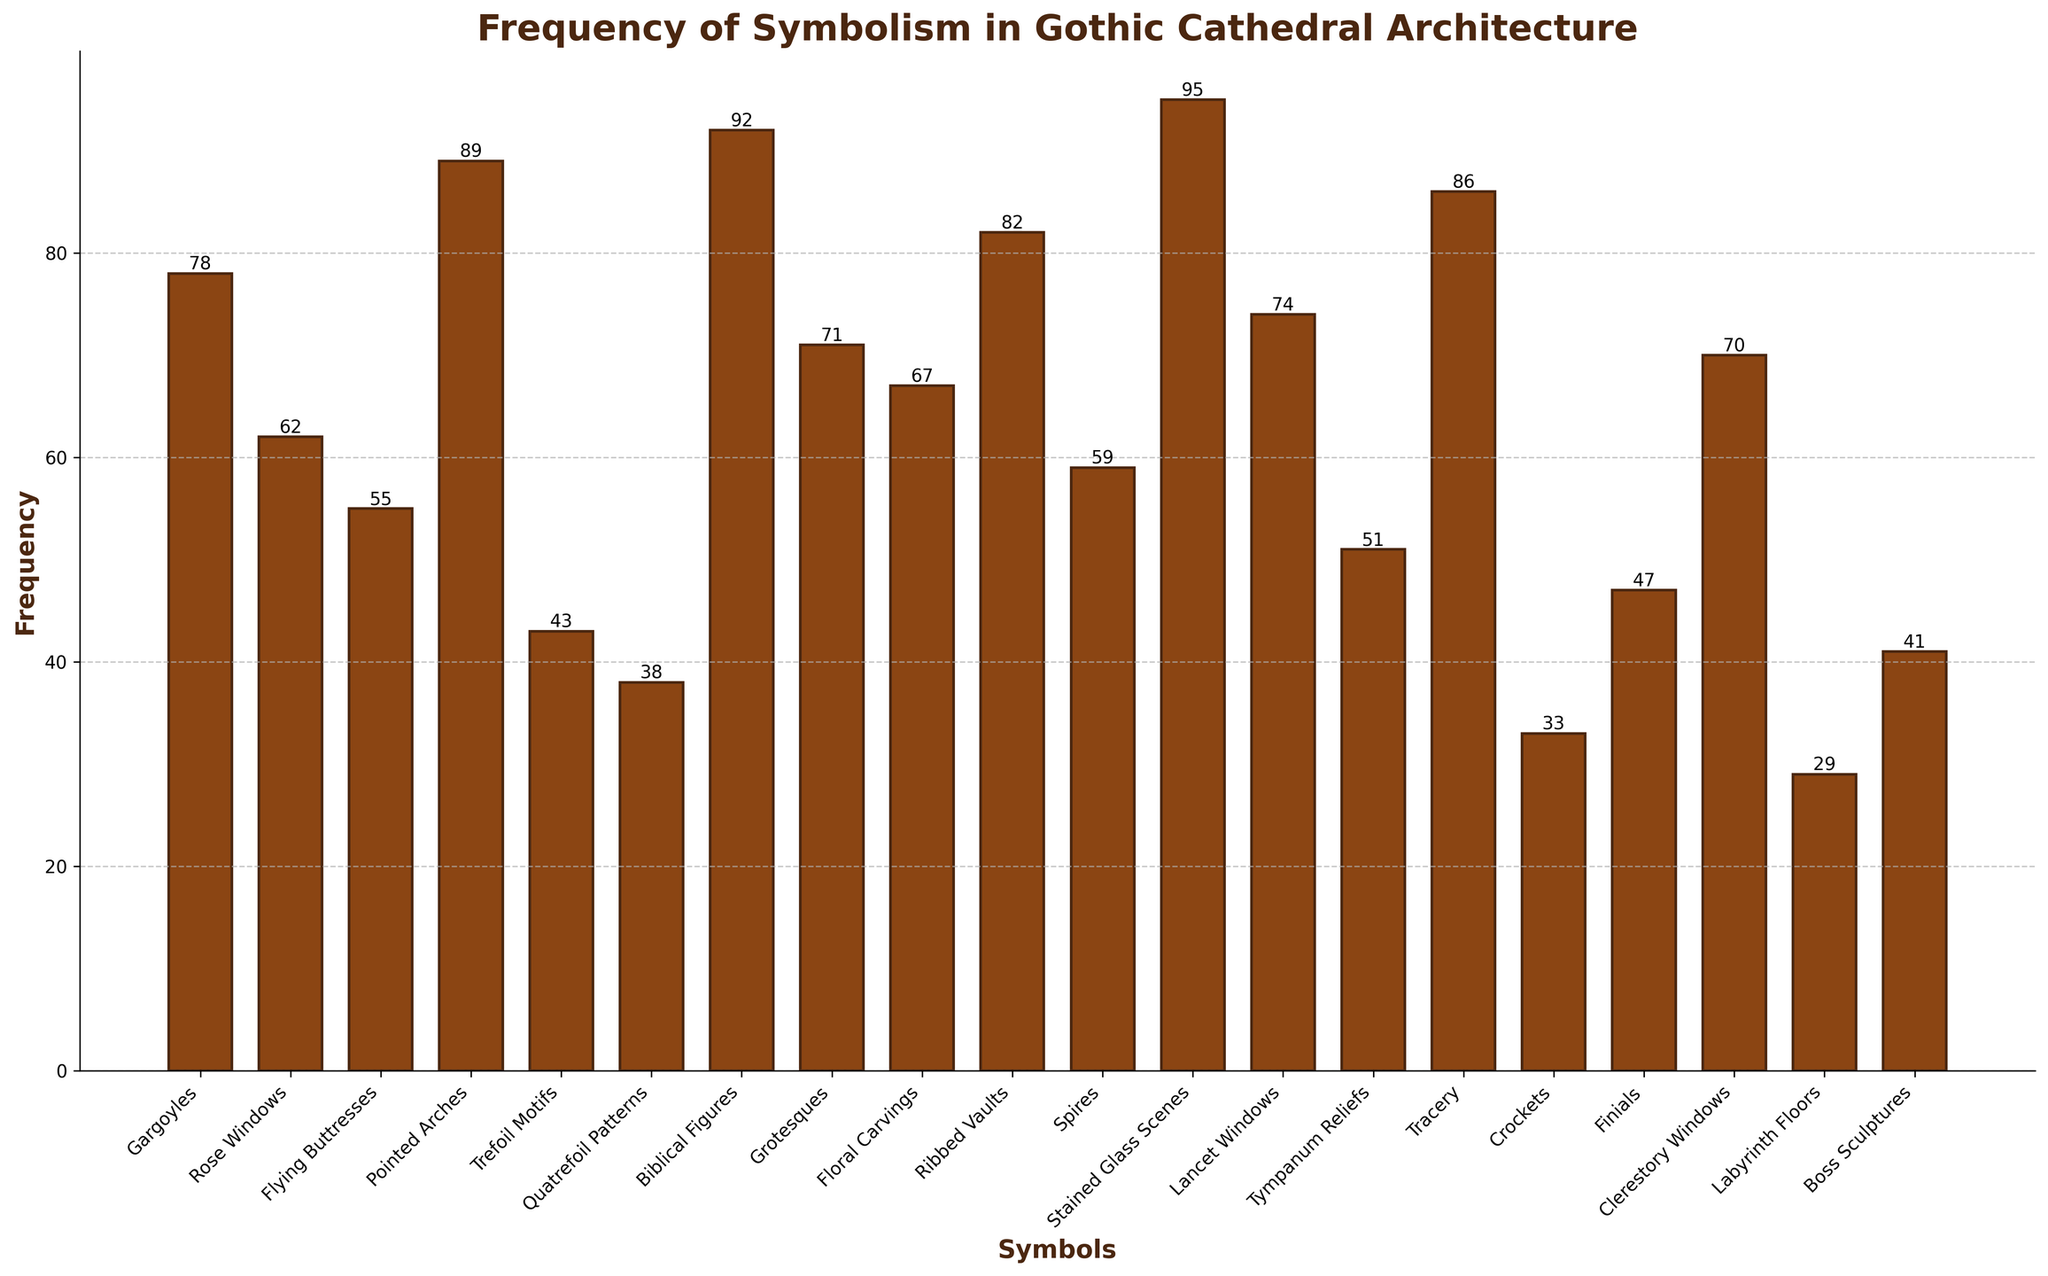What is the frequency of Biblical Figures in Gothic cathedral architecture? The figure presents bar heights corresponding to frequencies of different symbols. The bar labeled "Biblical Figures" reaches a height corresponding to 92.
Answer: 92 Which symbol appears more frequently: Gargoyles or Rose Windows? The heights of the bars labeled "Gargoyles" and "Rose Windows" show their respective frequencies. The height for Gargoyles is 78, while Rose Windows is 62. Since 78 is greater than 62, Gargoyles are more frequent.
Answer: Gargoyles What are the three least frequent symbols? The least frequent symbols are represented by the shortest bars in the figure. The bars with the smallest heights correspond to "Labyrinth Floors" (29), "Crockets" (33), and "Quatrefoil Patterns" (38).
Answer: Labyrinth Floors, Crockets, Quatrefoil Patterns How much more frequent are Pointed Arches than Trefoil Motifs? The bar for Pointed Arches has a frequency of 89 and Trefoil Motifs has 43. Subtract the frequency of Trefoil Motifs from that of Pointed Arches: 89 - 43 = 46.
Answer: 46 What symbols have frequencies greater than 80? Symbols with frequencies greater than 80 are represented by bars taller than the corresponding values on the y-axis. The bars for "Stained Glass Scenes" (95), "Biblical Figures" (92), "Ribbed Vaults" (82), "Pointed Arches" (89), and "Tracery" (86) exceed 80.
Answer: Stained Glass Scenes, Biblical Figures, Ribbed Vaults, Pointed Arches, Tracery What is the total frequency of symbols containing window-related elements? Sum the frequencies for symbols related to windows: "Rose Windows" (62), "Lancet Windows" (74), "Clerestory Windows" (70), "Stained Glass Scenes" (95). Add these values together: 62 + 74 + 70 + 95 = 301.
Answer: 301 Are Spires more or less frequent than Flying Buttresses? By comparing the heights of the bars for "Spires" (59) and "Flying Buttresses" (55), we see that the bar for Spires is slightly taller. Therefore, Spires are more frequent than Flying Buttresses.
Answer: More frequent What is the average frequency of the decorative symbols (Gargoyles, Grotesques, Floral Carvings)? Calculate the average frequency by summing the frequencies of "Gargoyles" (78), "Grotesques" (71), and "Floral Carvings" (67), then divide by the number of symbols: (78 + 71 + 67) / 3 = 72.
Answer: 72 